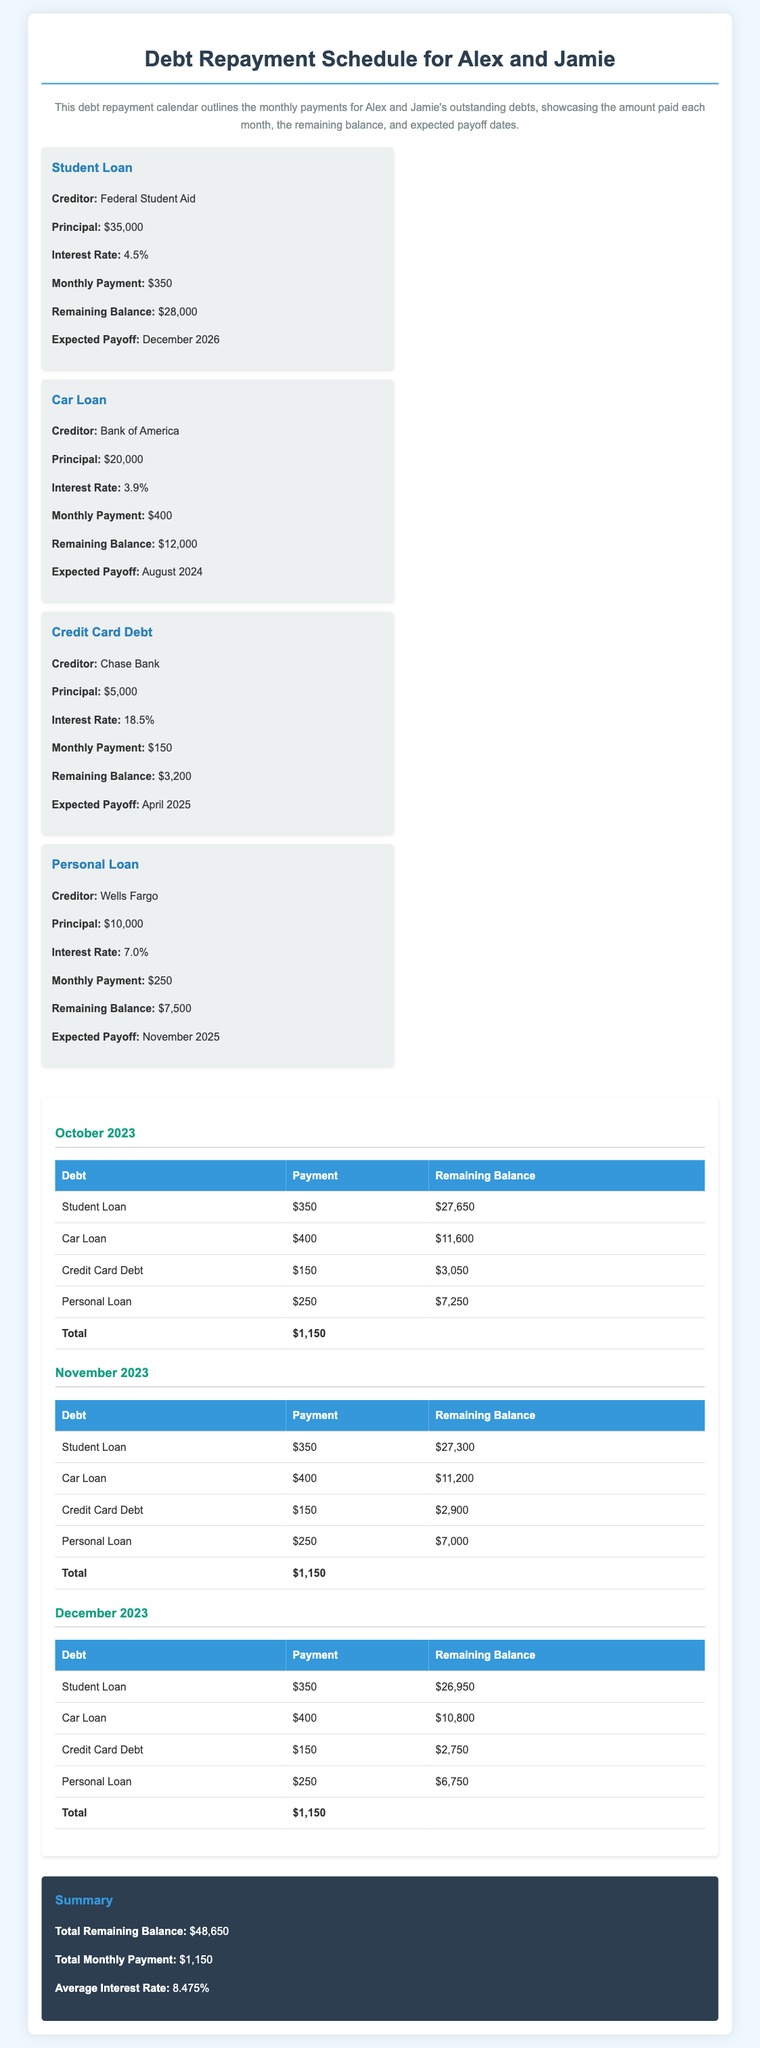What is the monthly payment for the Student Loan? The monthly payment for the Student Loan is stated in the document under the debt card for the Student Loan, which is $350.
Answer: $350 What is the remaining balance for the Car Loan in November 2023? The document provides the remaining balance for the Car Loan in the November 2023 section, which is $11,200.
Answer: $11,200 What is the total remaining balance across all debts? The total remaining balance is summarized at the end of the document, which totals $48,650.
Answer: $48,650 Which debt has the highest interest rate? The interest rates for each debt are listed, noting that the Credit Card Debt has the highest rate at 18.5%.
Answer: 18.5% When is the expected payoff date for the Personal Loan? The expected payoff date for the Personal Loan can be found under its debt card, which states November 2025.
Answer: November 2025 What is the average interest rate of all debts? The average interest rate is calculated and mentioned in the summary section of the document, which is 8.475%.
Answer: 8.475% How much do Alex and Jamie pay in total each month for all debts? The total monthly payment is summarized in the document, which states that they pay $1,150 in total each month.
Answer: $1,150 What creditor is associated with the Credit Card Debt? The creditor listed under the Credit Card Debt debt card is Chase Bank.
Answer: Chase Bank 